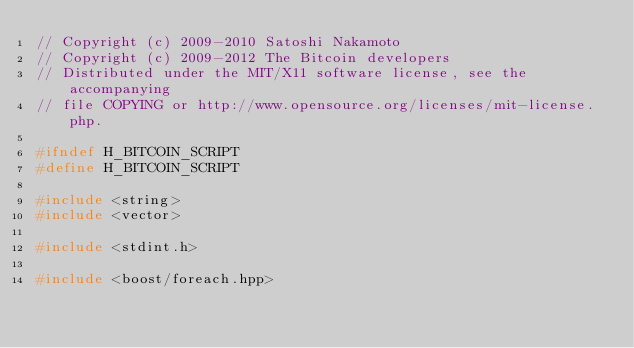<code> <loc_0><loc_0><loc_500><loc_500><_C_>// Copyright (c) 2009-2010 Satoshi Nakamoto
// Copyright (c) 2009-2012 The Bitcoin developers
// Distributed under the MIT/X11 software license, see the accompanying
// file COPYING or http://www.opensource.org/licenses/mit-license.php.

#ifndef H_BITCOIN_SCRIPT
#define H_BITCOIN_SCRIPT

#include <string>
#include <vector>

#include <stdint.h>

#include <boost/foreach.hpp></code> 